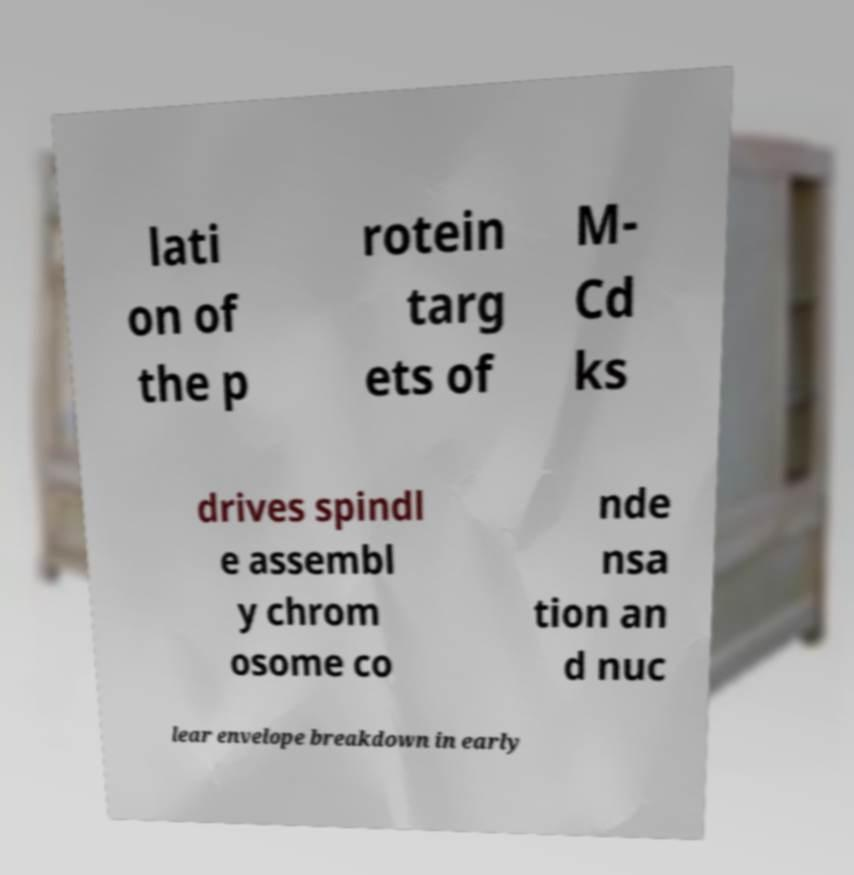What messages or text are displayed in this image? I need them in a readable, typed format. lati on of the p rotein targ ets of M- Cd ks drives spindl e assembl y chrom osome co nde nsa tion an d nuc lear envelope breakdown in early 